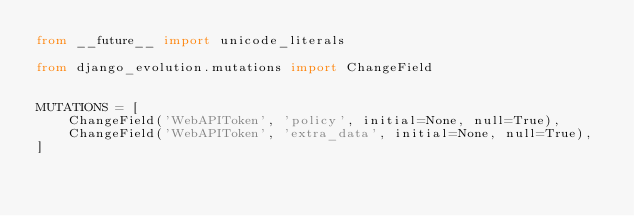Convert code to text. <code><loc_0><loc_0><loc_500><loc_500><_Python_>from __future__ import unicode_literals

from django_evolution.mutations import ChangeField


MUTATIONS = [
    ChangeField('WebAPIToken', 'policy', initial=None, null=True),
    ChangeField('WebAPIToken', 'extra_data', initial=None, null=True),
]
</code> 